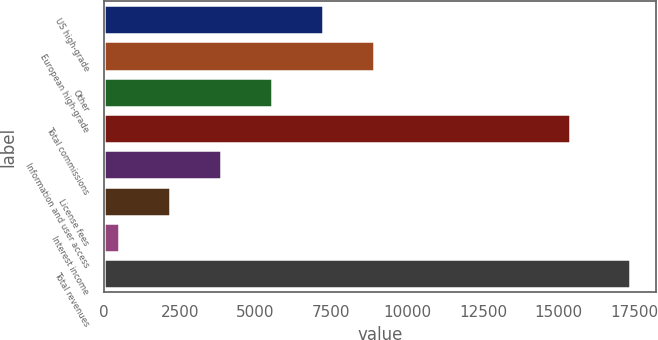<chart> <loc_0><loc_0><loc_500><loc_500><bar_chart><fcel>US high-grade<fcel>European high-grade<fcel>Other<fcel>Total commissions<fcel>Information and user access<fcel>License fees<fcel>Interest income<fcel>Total revenues<nl><fcel>7241.4<fcel>8924<fcel>5558.8<fcel>15372<fcel>3876.2<fcel>2193.6<fcel>511<fcel>17337<nl></chart> 